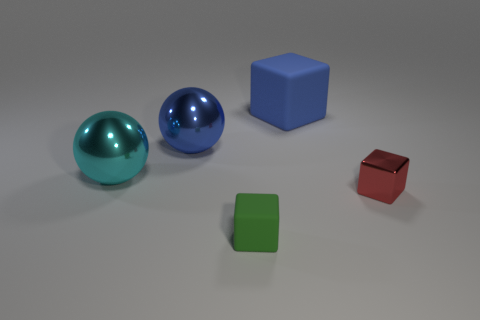What is the shape of the shiny thing that is on the left side of the green cube and right of the cyan thing?
Give a very brief answer. Sphere. There is a matte thing that is in front of the blue metal thing; is it the same shape as the cyan shiny thing?
Make the answer very short. No. What number of brown objects are either tiny matte blocks or metallic cubes?
Your response must be concise. 0. What material is the tiny red thing that is the same shape as the large blue rubber object?
Your response must be concise. Metal. What shape is the small object right of the blue matte cube?
Keep it short and to the point. Cube. Are there any brown cylinders made of the same material as the cyan ball?
Provide a short and direct response. No. Is the size of the blue sphere the same as the green cube?
Your response must be concise. No. How many cylinders are small red things or blue shiny things?
Offer a very short reply. 0. There is a sphere that is the same color as the large cube; what is its material?
Your answer should be very brief. Metal. How many other small green objects have the same shape as the small metallic thing?
Provide a short and direct response. 1. 